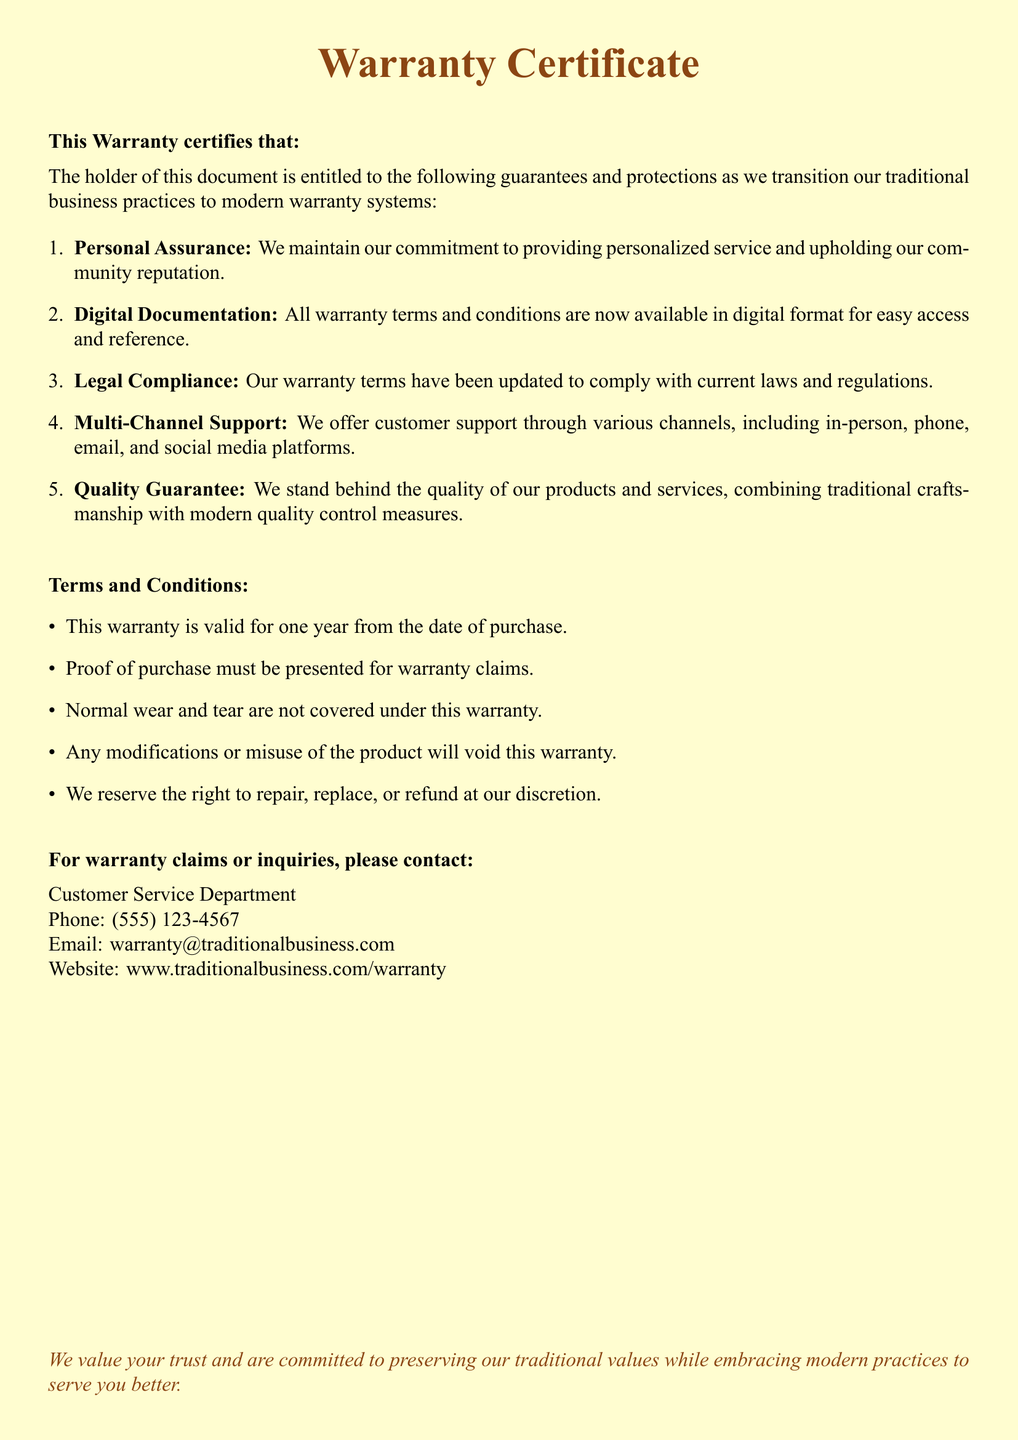What is the warranty validity period? The document states that this warranty is valid for one year from the date of purchase.
Answer: one year What should be presented for warranty claims? According to the document, proof of purchase must be presented for warranty claims.
Answer: proof of purchase Which department should be contacted for inquiries? The document specifies that the Customer Service Department should be contacted for warranty claims or inquiries.
Answer: Customer Service Department What is covered under this warranty? The document notes that normal wear and tear are not covered under this warranty.
Answer: normal wear and tear What is combined with modern quality control measures? The document mentions that the quality guarantee combines traditional craftsmanship with modern quality control measures.
Answer: traditional craftsmanship How can customer support be accessed? The document provides various channels for support including in-person, phone, email, and social media platforms, indicating multi-channel support.
Answer: multi-channel support What happens if the product is modified? The document states that any modifications or misuse of the product will void this warranty.
Answer: void this warranty What type of documentation is provided for warranty terms? The document indicates that all warranty terms and conditions are now available in digital format.
Answer: digital format 